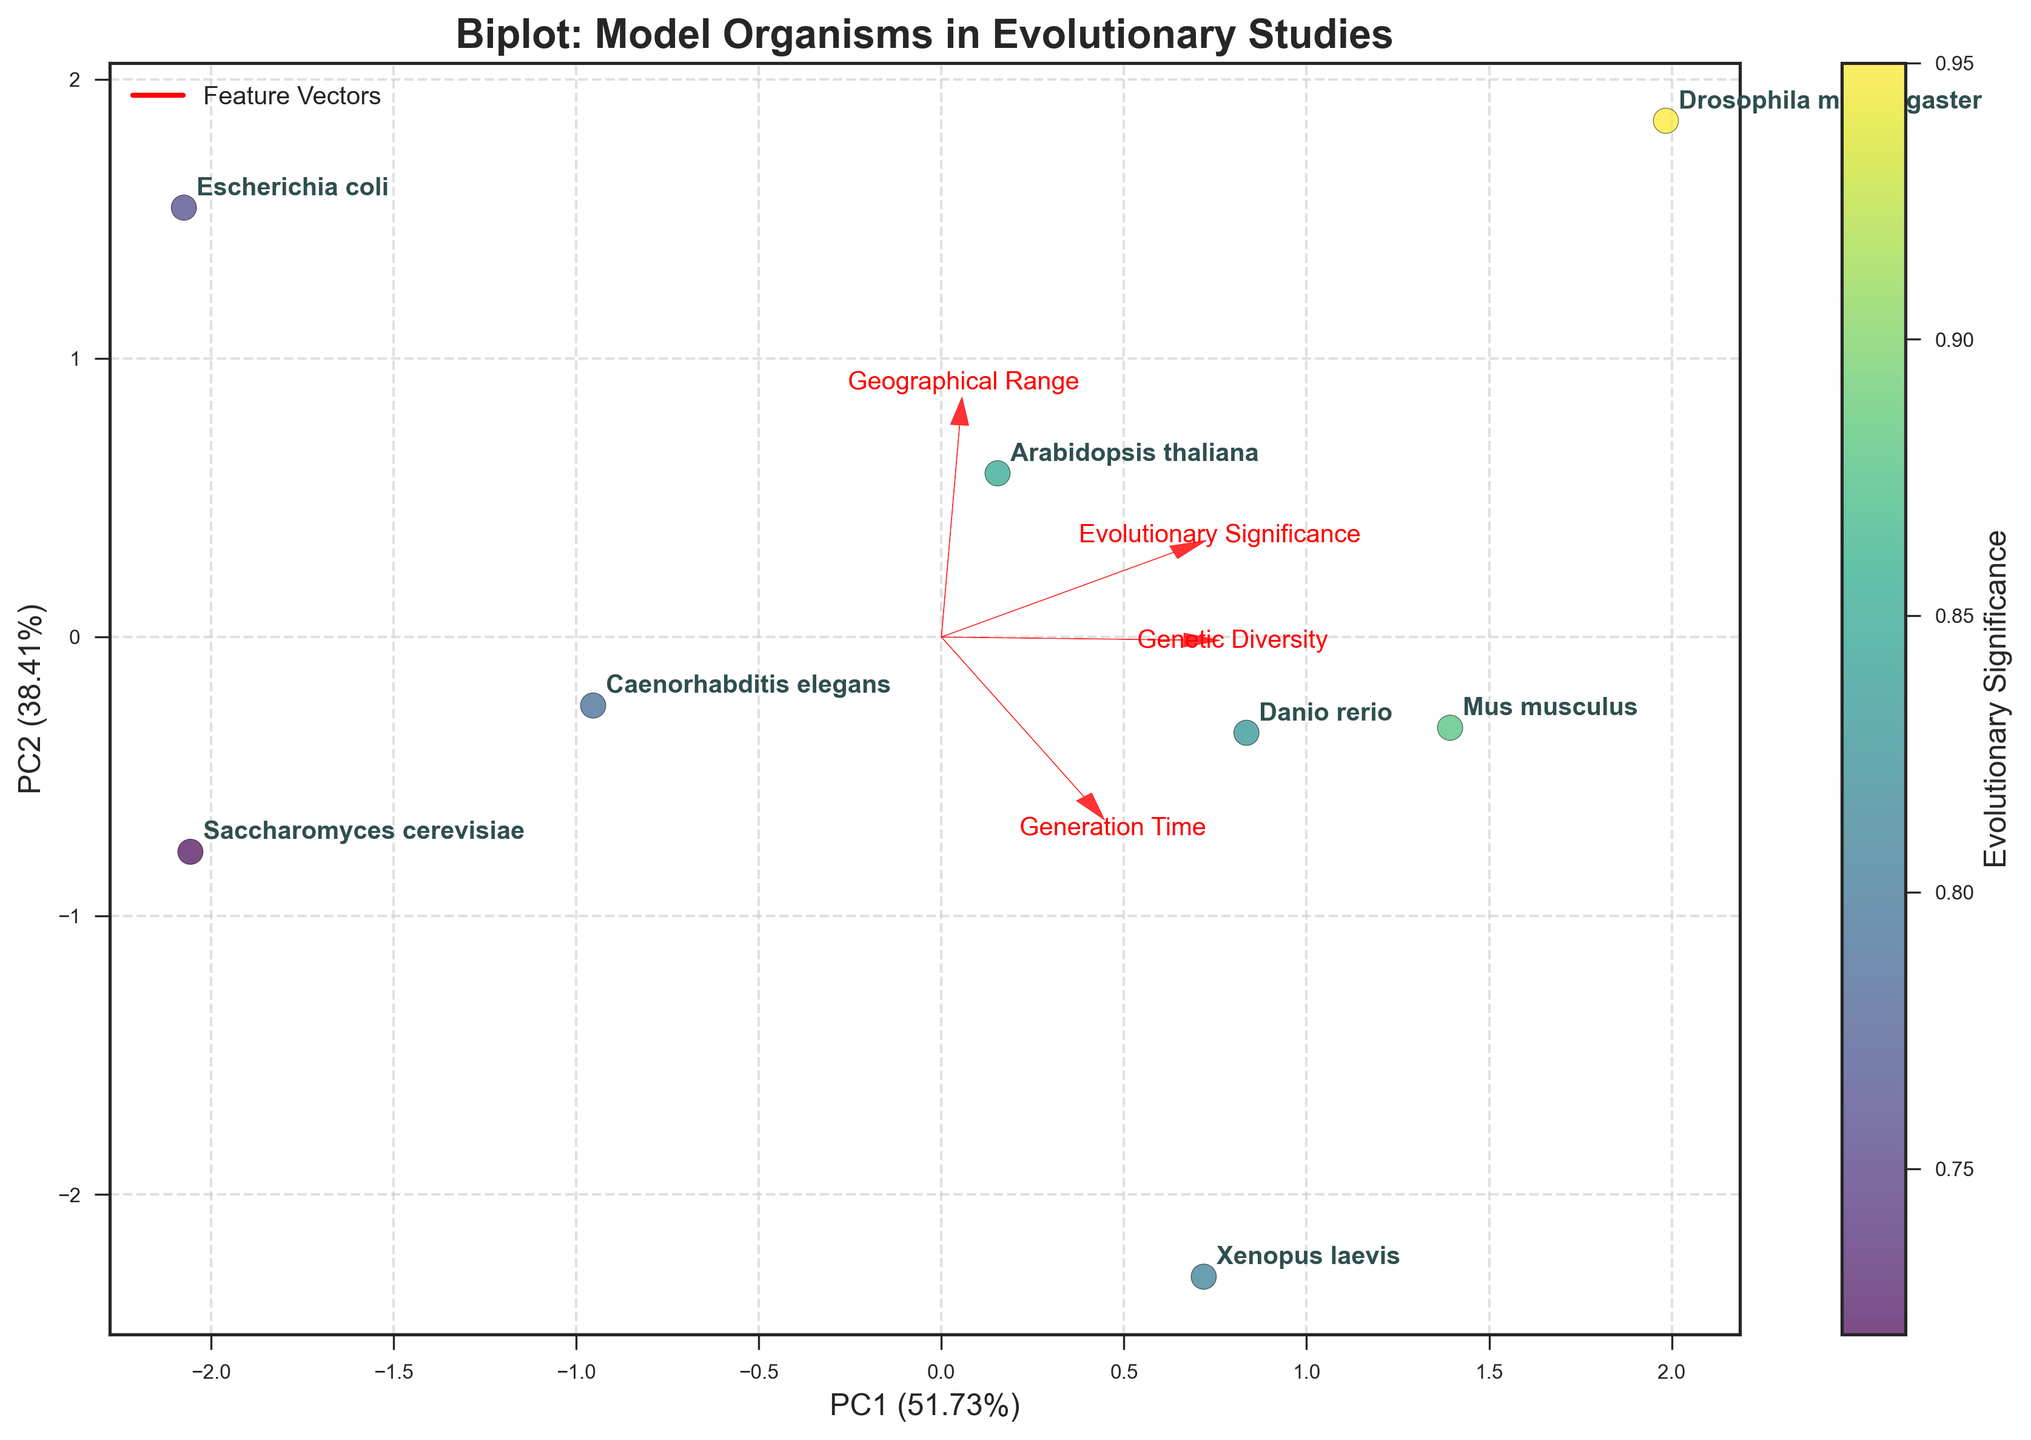What is the title of the biplot? The title of a plot is usually displayed at the top of the figure, written in larger or bold text to distinguish it from other labels and elements.
Answer: Biplot: Model Organisms in Evolutionary Studies Which organism has the shortest generation time according to the plot? The data points are labeled with species names, and one can identify the organism with the smallest generation time by looking at the placement of the points along the relevant axis or using the feature vectors, where one might see the arrow for "Generation Time".
Answer: Escherichia coli How many organisms are plotted in the biplot? By counting the data points or the species labels annotated in the plot, we can determine the number of organisms presented.
Answer: Eight Which feature has the highest correlation with PC1? The feature vectors (arrows) provide direction and magnitude, and the feature vector most aligned with the horizontal axis (PC1) represents the highest correlation with PC1.
Answer: Genetic Diversity What is the relationship between Genetic Diversity and Evolutionary Significance according to the plot? Analyze the direction and length of feature vectors for Genetic Diversity and Evolutionary Significance. If they point in similar directions, it indicates a positive correlation, otherwise, the opposite or no correlation.
Answer: Positive correlation Which organism is placed closest to the origin in the biplot? Identify the point that is nearest to the (0,0) coordinate on the plot.
Answer: Saccharomyces cerevisiae Between Drosophila melanogaster and Danio rerio, which organism has a higher Evolutionary Significance? Compare the color or position of the points corresponding to these species. Higher values are closer to yellow, lower closer to dark blue.
Answer: Drosophila melanogaster Which features have similar weights on PC2? Examine the arrows cut across the vertical axis (PC2) and determine which feature vectors point in similar directions.
Answer: Geographical Range and Evolutionary Significance What do the red arrows represent on the plot? The description provided indicates that the plot includes feature vectors in red, used to represent each feature's direction and magnitude in the Principal Component Analysis.
Answer: Feature vectors How well do the first two principal components explain the data variance? The explanation for PC1 and PC2 percentages can be found in the axis labels. Add these two percentages to find the combined variance explanation.
Answer: ~63% 